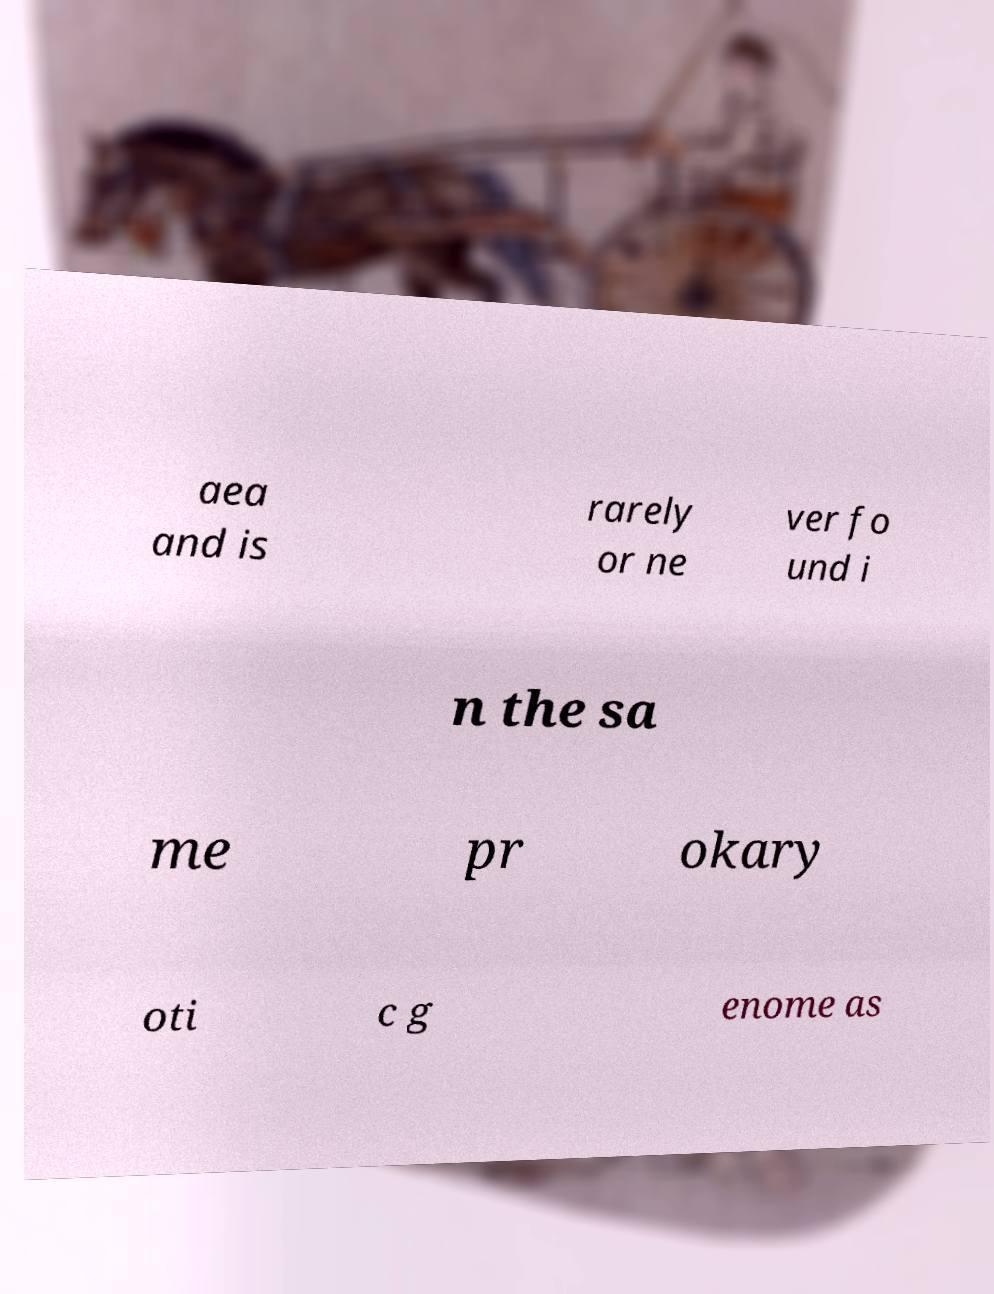Can you accurately transcribe the text from the provided image for me? aea and is rarely or ne ver fo und i n the sa me pr okary oti c g enome as 